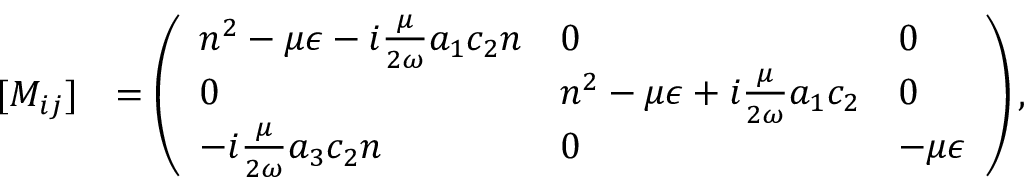Convert formula to latex. <formula><loc_0><loc_0><loc_500><loc_500>\begin{array} { r l } { [ M _ { i j } ] } & { = \left ( \begin{array} { l l l } { n ^ { 2 } - \mu { \epsilon } - i \frac { \mu } { 2 \omega } a _ { 1 } c _ { 2 } n } & { 0 } & { 0 } \\ { 0 } & { n ^ { 2 } - \mu { \epsilon } + i \frac { \mu } { 2 \omega } a _ { 1 } c _ { 2 } } & { 0 } \\ { - i \frac { \mu } { 2 \omega } a _ { 3 } c _ { 2 } n } & { 0 } & { - \mu { \epsilon } } \end{array} \right ) , } \end{array}</formula> 